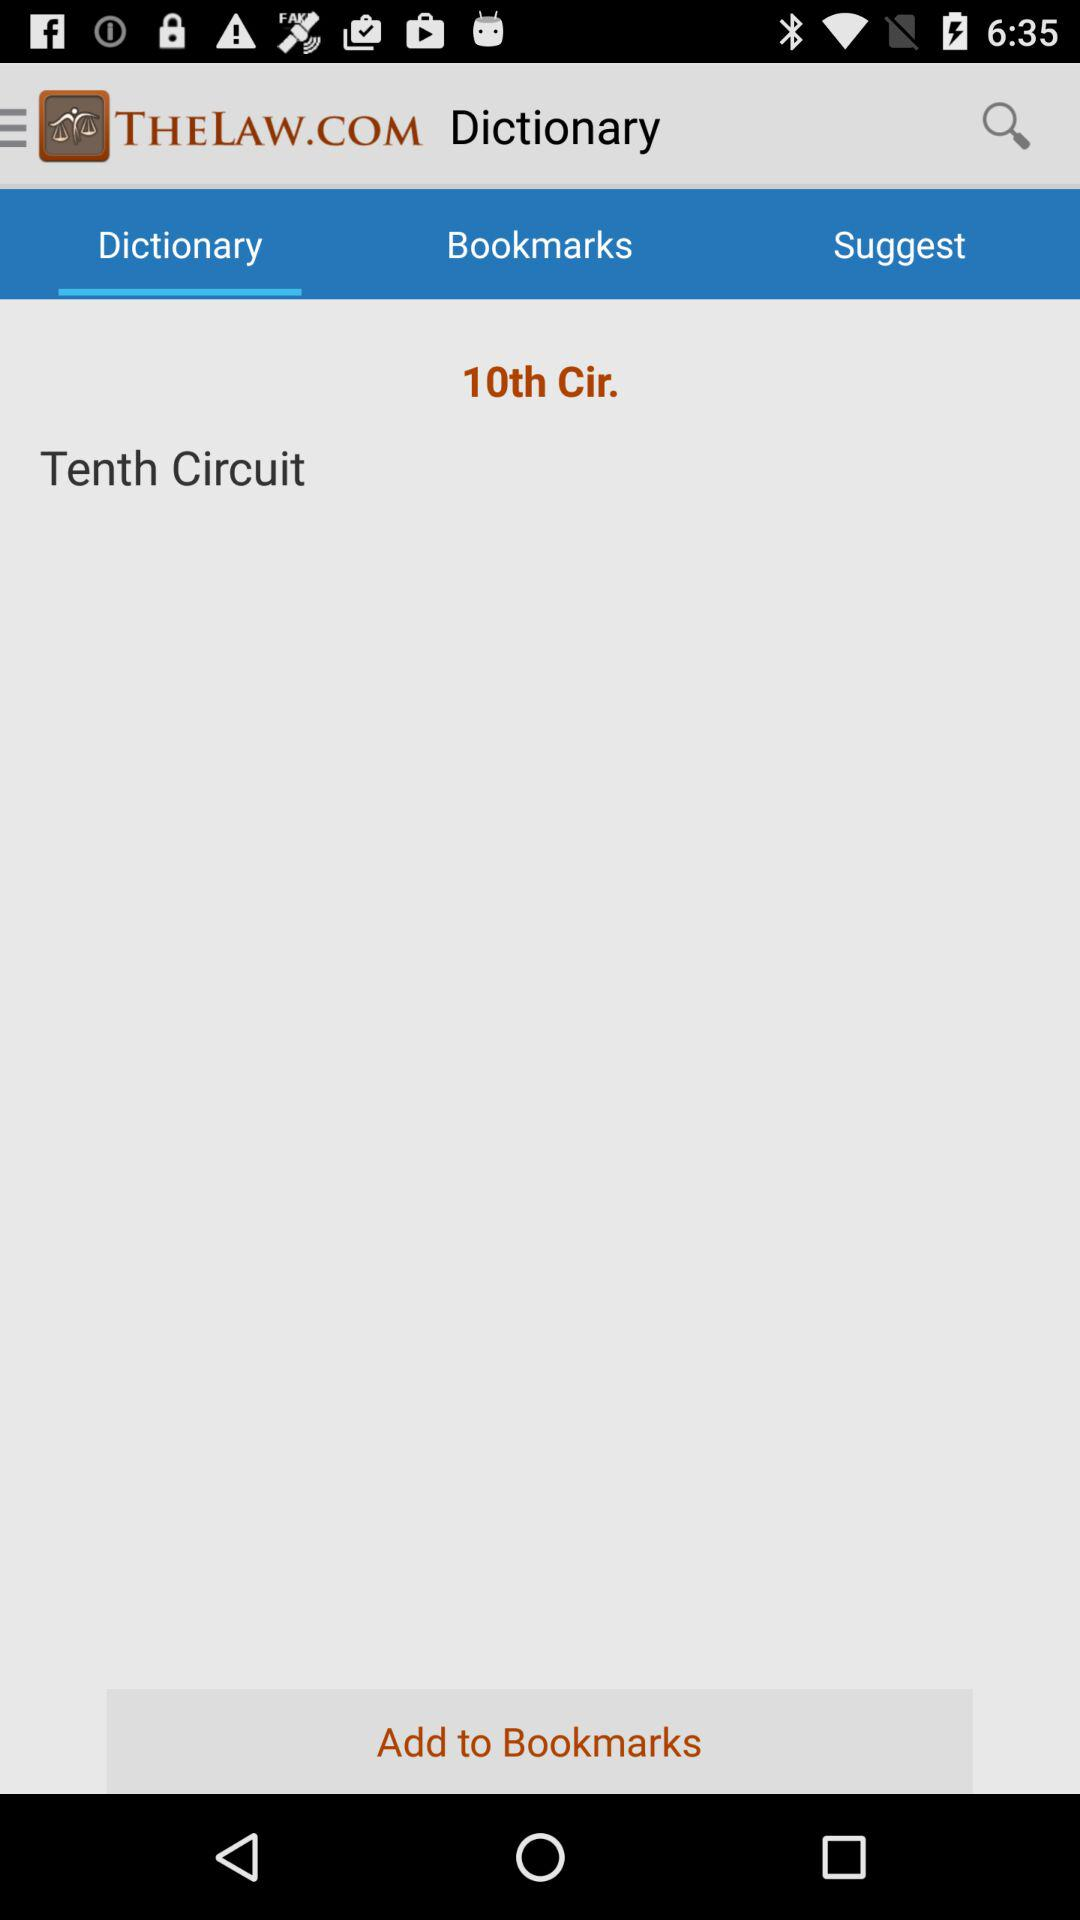Why would someone use this mobile app feature? A user might access the 'Dictionary' feature in a legal app like the one shown to look up specific legal terms, acronyms, or phrases. This can be especially useful for students, legal professionals or anyone interested in gaining a clearer understanding of legal terminology.  How do you think this app compares to other legal resources online? This app appears to provide concise, direct access to legal terms, potentially making it a quick reference tool as opposed to more comprehensive but time-consuming online resources, like legal databases that offer detailed case law analyses, legal articles, and publications. 